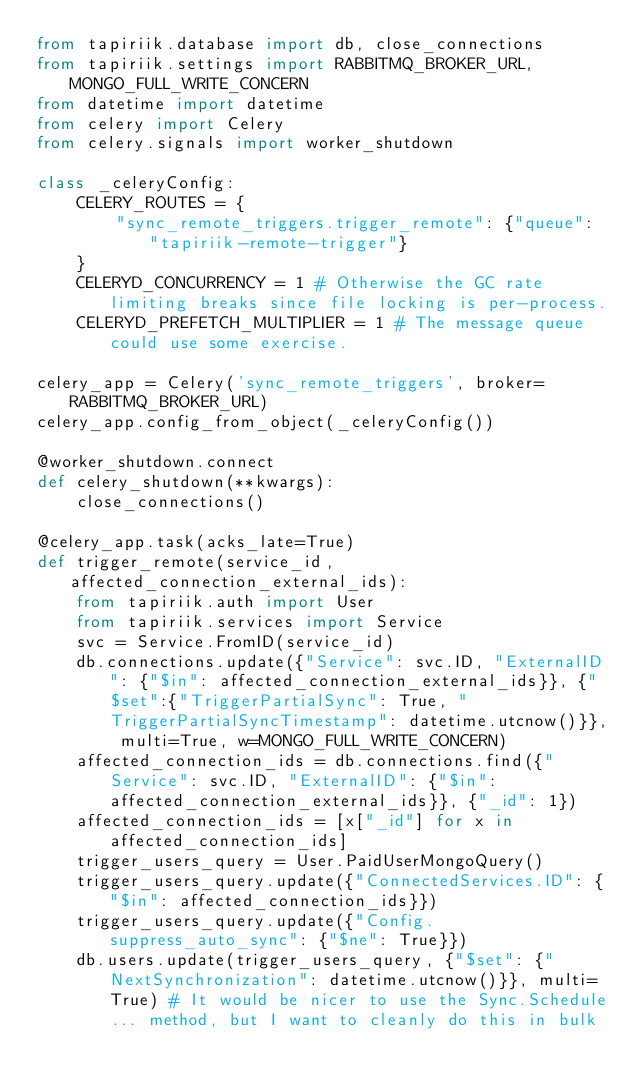<code> <loc_0><loc_0><loc_500><loc_500><_Python_>from tapiriik.database import db, close_connections
from tapiriik.settings import RABBITMQ_BROKER_URL, MONGO_FULL_WRITE_CONCERN
from datetime import datetime
from celery import Celery
from celery.signals import worker_shutdown

class _celeryConfig:
    CELERY_ROUTES = {
        "sync_remote_triggers.trigger_remote": {"queue": "tapiriik-remote-trigger"}
    }
    CELERYD_CONCURRENCY = 1 # Otherwise the GC rate limiting breaks since file locking is per-process.
    CELERYD_PREFETCH_MULTIPLIER = 1 # The message queue could use some exercise.

celery_app = Celery('sync_remote_triggers', broker=RABBITMQ_BROKER_URL)
celery_app.config_from_object(_celeryConfig())

@worker_shutdown.connect
def celery_shutdown(**kwargs):
    close_connections()

@celery_app.task(acks_late=True)
def trigger_remote(service_id, affected_connection_external_ids):
    from tapiriik.auth import User
    from tapiriik.services import Service
    svc = Service.FromID(service_id)
    db.connections.update({"Service": svc.ID, "ExternalID": {"$in": affected_connection_external_ids}}, {"$set":{"TriggerPartialSync": True, "TriggerPartialSyncTimestamp": datetime.utcnow()}}, multi=True, w=MONGO_FULL_WRITE_CONCERN)
    affected_connection_ids = db.connections.find({"Service": svc.ID, "ExternalID": {"$in": affected_connection_external_ids}}, {"_id": 1})
    affected_connection_ids = [x["_id"] for x in affected_connection_ids]
    trigger_users_query = User.PaidUserMongoQuery()
    trigger_users_query.update({"ConnectedServices.ID": {"$in": affected_connection_ids}})
    trigger_users_query.update({"Config.suppress_auto_sync": {"$ne": True}})
    db.users.update(trigger_users_query, {"$set": {"NextSynchronization": datetime.utcnow()}}, multi=True) # It would be nicer to use the Sync.Schedule... method, but I want to cleanly do this in bulk
</code> 